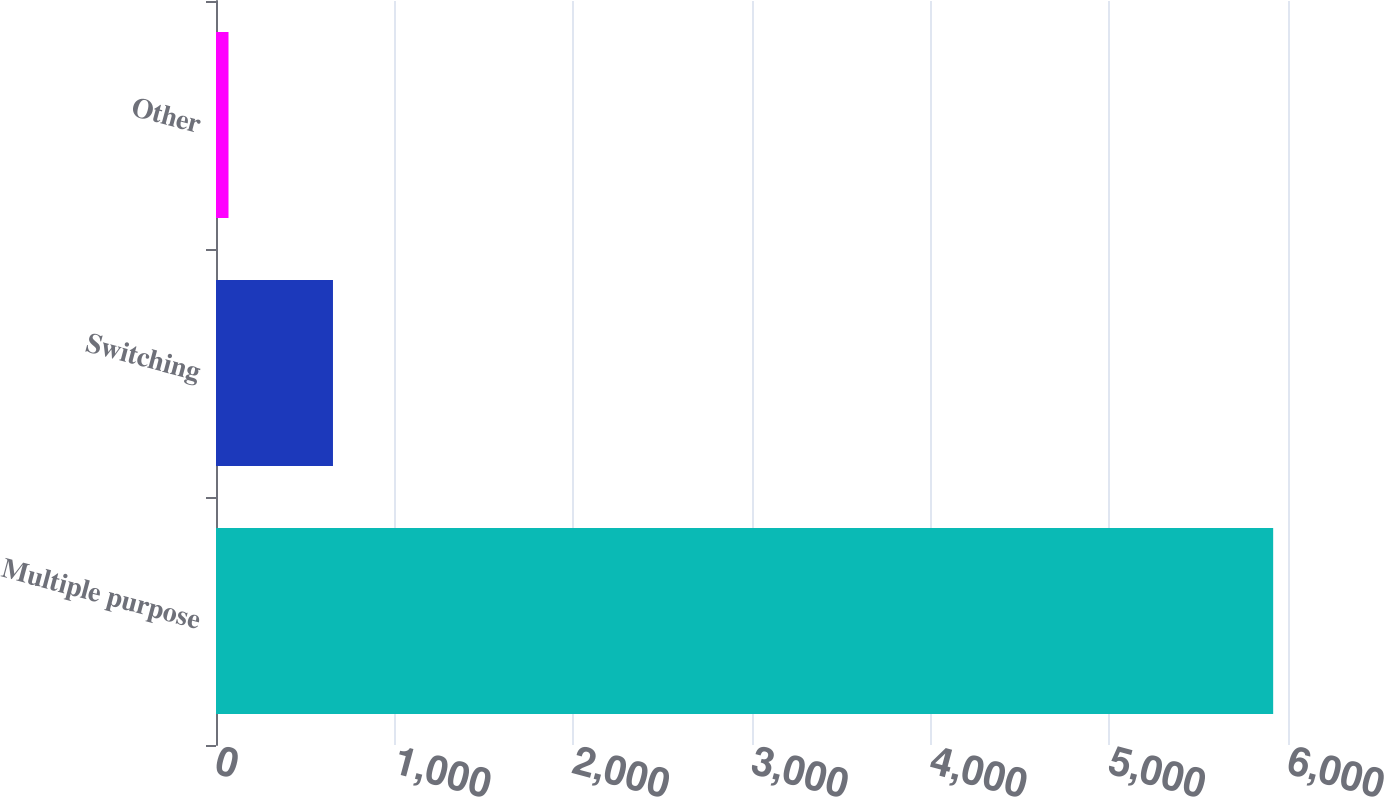Convert chart to OTSL. <chart><loc_0><loc_0><loc_500><loc_500><bar_chart><fcel>Multiple purpose<fcel>Switching<fcel>Other<nl><fcel>5917<fcel>654.7<fcel>70<nl></chart> 